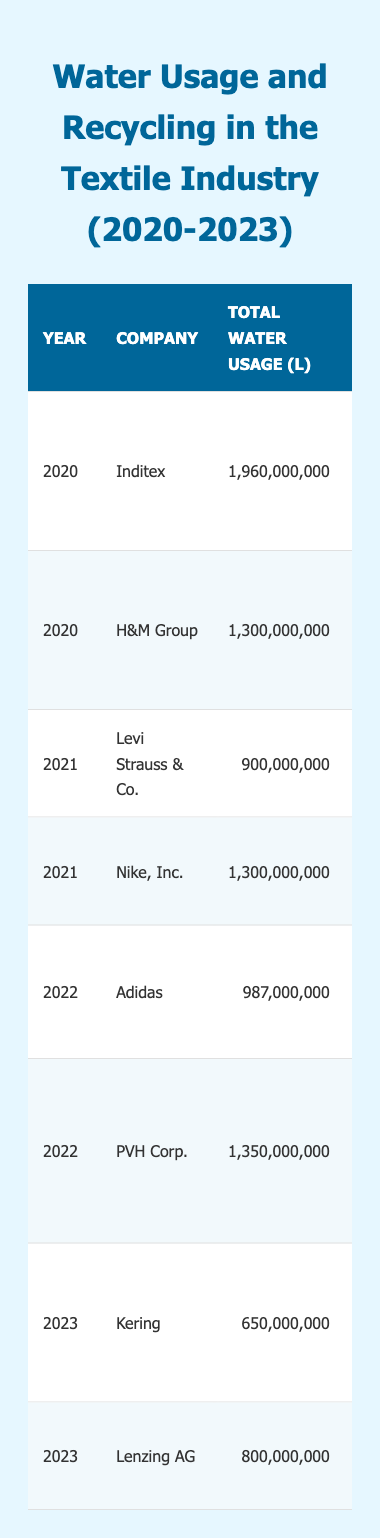What is the total water usage of H&M Group in 2020? From the table, we can see that the total water usage for H&M Group in 2020 is listed as 1,300,000,000 liters.
Answer: 1,300,000,000 liters Which company had the highest recycling rate in 2021? By comparing the recycling rates for the companies listed in 2021, Levi Strauss & Co. had a recycling rate of 33%, while Nike, Inc. had a rate of 30%. Therefore, Levi Strauss & Co. had the highest recycling rate in that year.
Answer: Levi Strauss & Co What was the recycling rate of Adidas in 2022? According to the table, Adidas had a recycling rate of 25% in 2022.
Answer: 25% How much water was recycled by Lenzing AG in 2023? The table specifies that Lenzing AG recycled 320,000,000 liters of water in 2023.
Answer: 320,000,000 liters What is the average recycling rate from 2020 to 2023? To find the average, we first add the recycling rates: 29% (2020) + 35% (2020) + 33% (2021) + 30% (2021) + 25% (2022) + 30% (2022) + 30% (2023) + 40% (2023) = 312%. Then, divide this total by 8 (the number of data points) to get 39%.
Answer: 39% What is the difference in total water usage from 2020 (Inditex) to 2023 (Kering)? Inditex had a total water usage of 1,960,000,000 liters in 2020, and Kering had 650,000,000 liters in 2023. The difference is 1,960,000,000 - 650,000,000 = 1,310,000,000 liters.
Answer: 1,310,000,000 liters Did any company completely stop recycling water by 2023? Checking the recycling figures in the table, all companies listed had a recycling rate greater than 0%, so no company completely stopped recycling water by 2023.
Answer: No Which company had the lowest total water usage in 2022? The table shows that Adidas had the lowest total water usage in 2022 at 987,000,000 liters, compared to PVH Corp. at 1,350,000,000 liters.
Answer: Adidas Which company's major initiatives include the "Water Stewardship Program"? The major initiatives for Inditex listed in the table include the "Water Stewardship Program," thus making it the correct answer.
Answer: Inditex What was the total water usage of Levi Strauss & Co. compared to Nike, Inc. in 2021? Levi Strauss & Co. used 900,000,000 liters, while Nike, Inc. used 1,300,000,000 liters in 2021. The comparison shows that Nike, Inc. used more water than Levi Strauss & Co.
Answer: Nike, Inc. used more water 